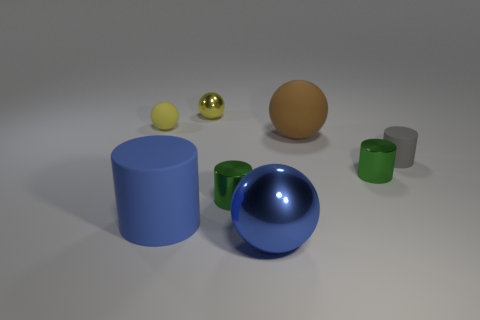Is there anything else that is the same size as the yellow metal object?
Provide a succinct answer. Yes. What number of balls have the same color as the large cylinder?
Make the answer very short. 1. There is another ball that is the same color as the tiny metal ball; what size is it?
Ensure brevity in your answer.  Small. There is a big ball that is in front of the blue matte cylinder; does it have the same color as the rubber object that is in front of the tiny gray cylinder?
Your answer should be very brief. Yes. Is the large metal thing the same color as the large cylinder?
Your response must be concise. Yes. Is there any other thing that has the same color as the tiny metallic sphere?
Ensure brevity in your answer.  Yes. What is the shape of the large object that is the same color as the large rubber cylinder?
Offer a terse response. Sphere. There is a small rubber object that is on the left side of the blue thing that is in front of the blue cylinder; what shape is it?
Your response must be concise. Sphere. There is a yellow shiny object that is the same size as the gray rubber cylinder; what shape is it?
Ensure brevity in your answer.  Sphere. Is there a rubber cube of the same color as the big shiny sphere?
Keep it short and to the point. No. 